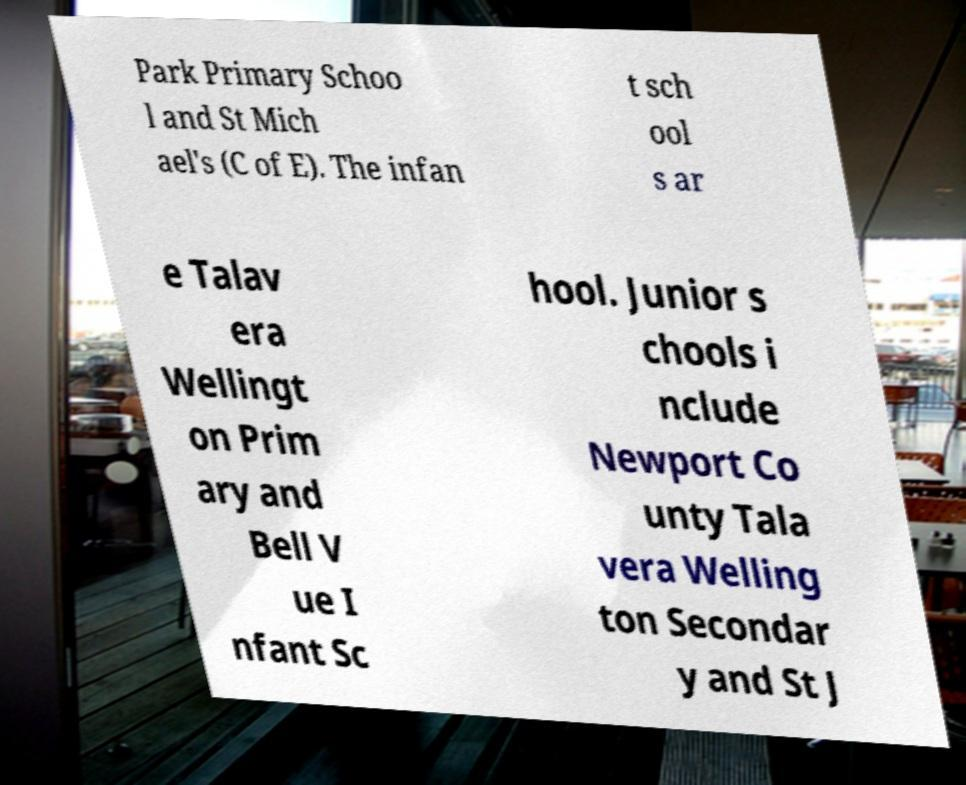Could you assist in decoding the text presented in this image and type it out clearly? Park Primary Schoo l and St Mich ael's (C of E). The infan t sch ool s ar e Talav era Wellingt on Prim ary and Bell V ue I nfant Sc hool. Junior s chools i nclude Newport Co unty Tala vera Welling ton Secondar y and St J 